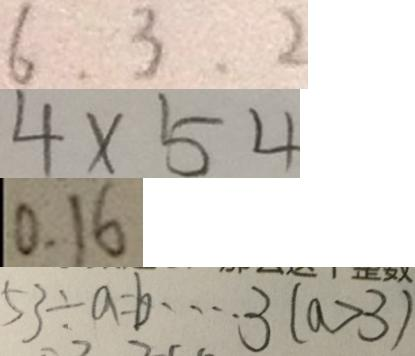Convert formula to latex. <formula><loc_0><loc_0><loc_500><loc_500>6 , 3 , 2 
 4 \times 5 4 
 0 . 1 6 
 5 3 \div a = b \cdots 3 ( a > 3 )</formula> 